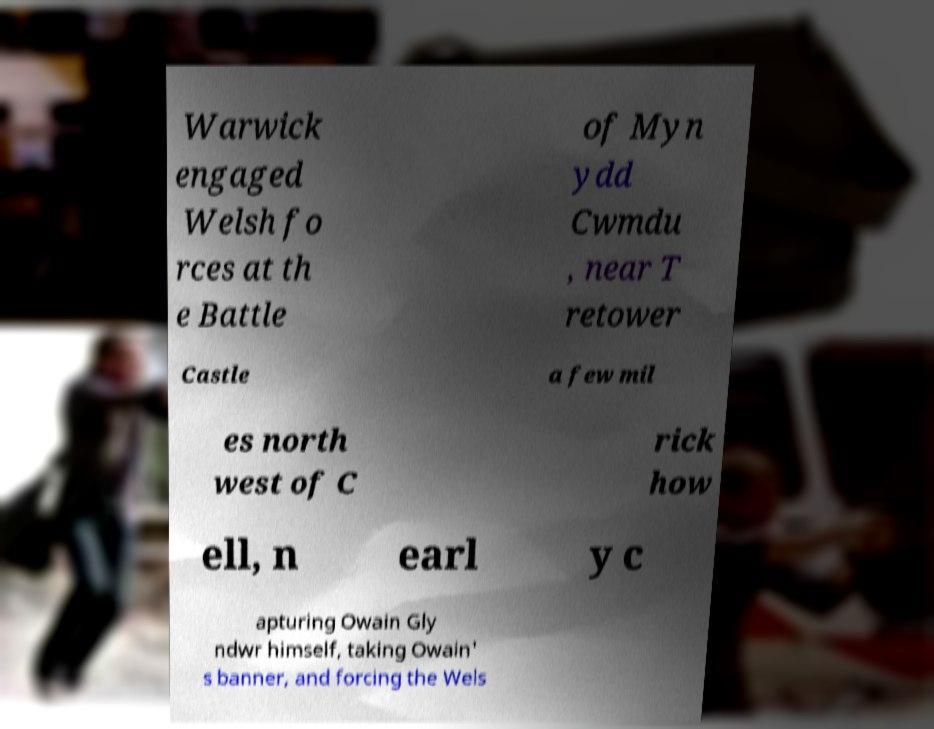Can you read and provide the text displayed in the image?This photo seems to have some interesting text. Can you extract and type it out for me? Warwick engaged Welsh fo rces at th e Battle of Myn ydd Cwmdu , near T retower Castle a few mil es north west of C rick how ell, n earl y c apturing Owain Gly ndwr himself, taking Owain' s banner, and forcing the Wels 